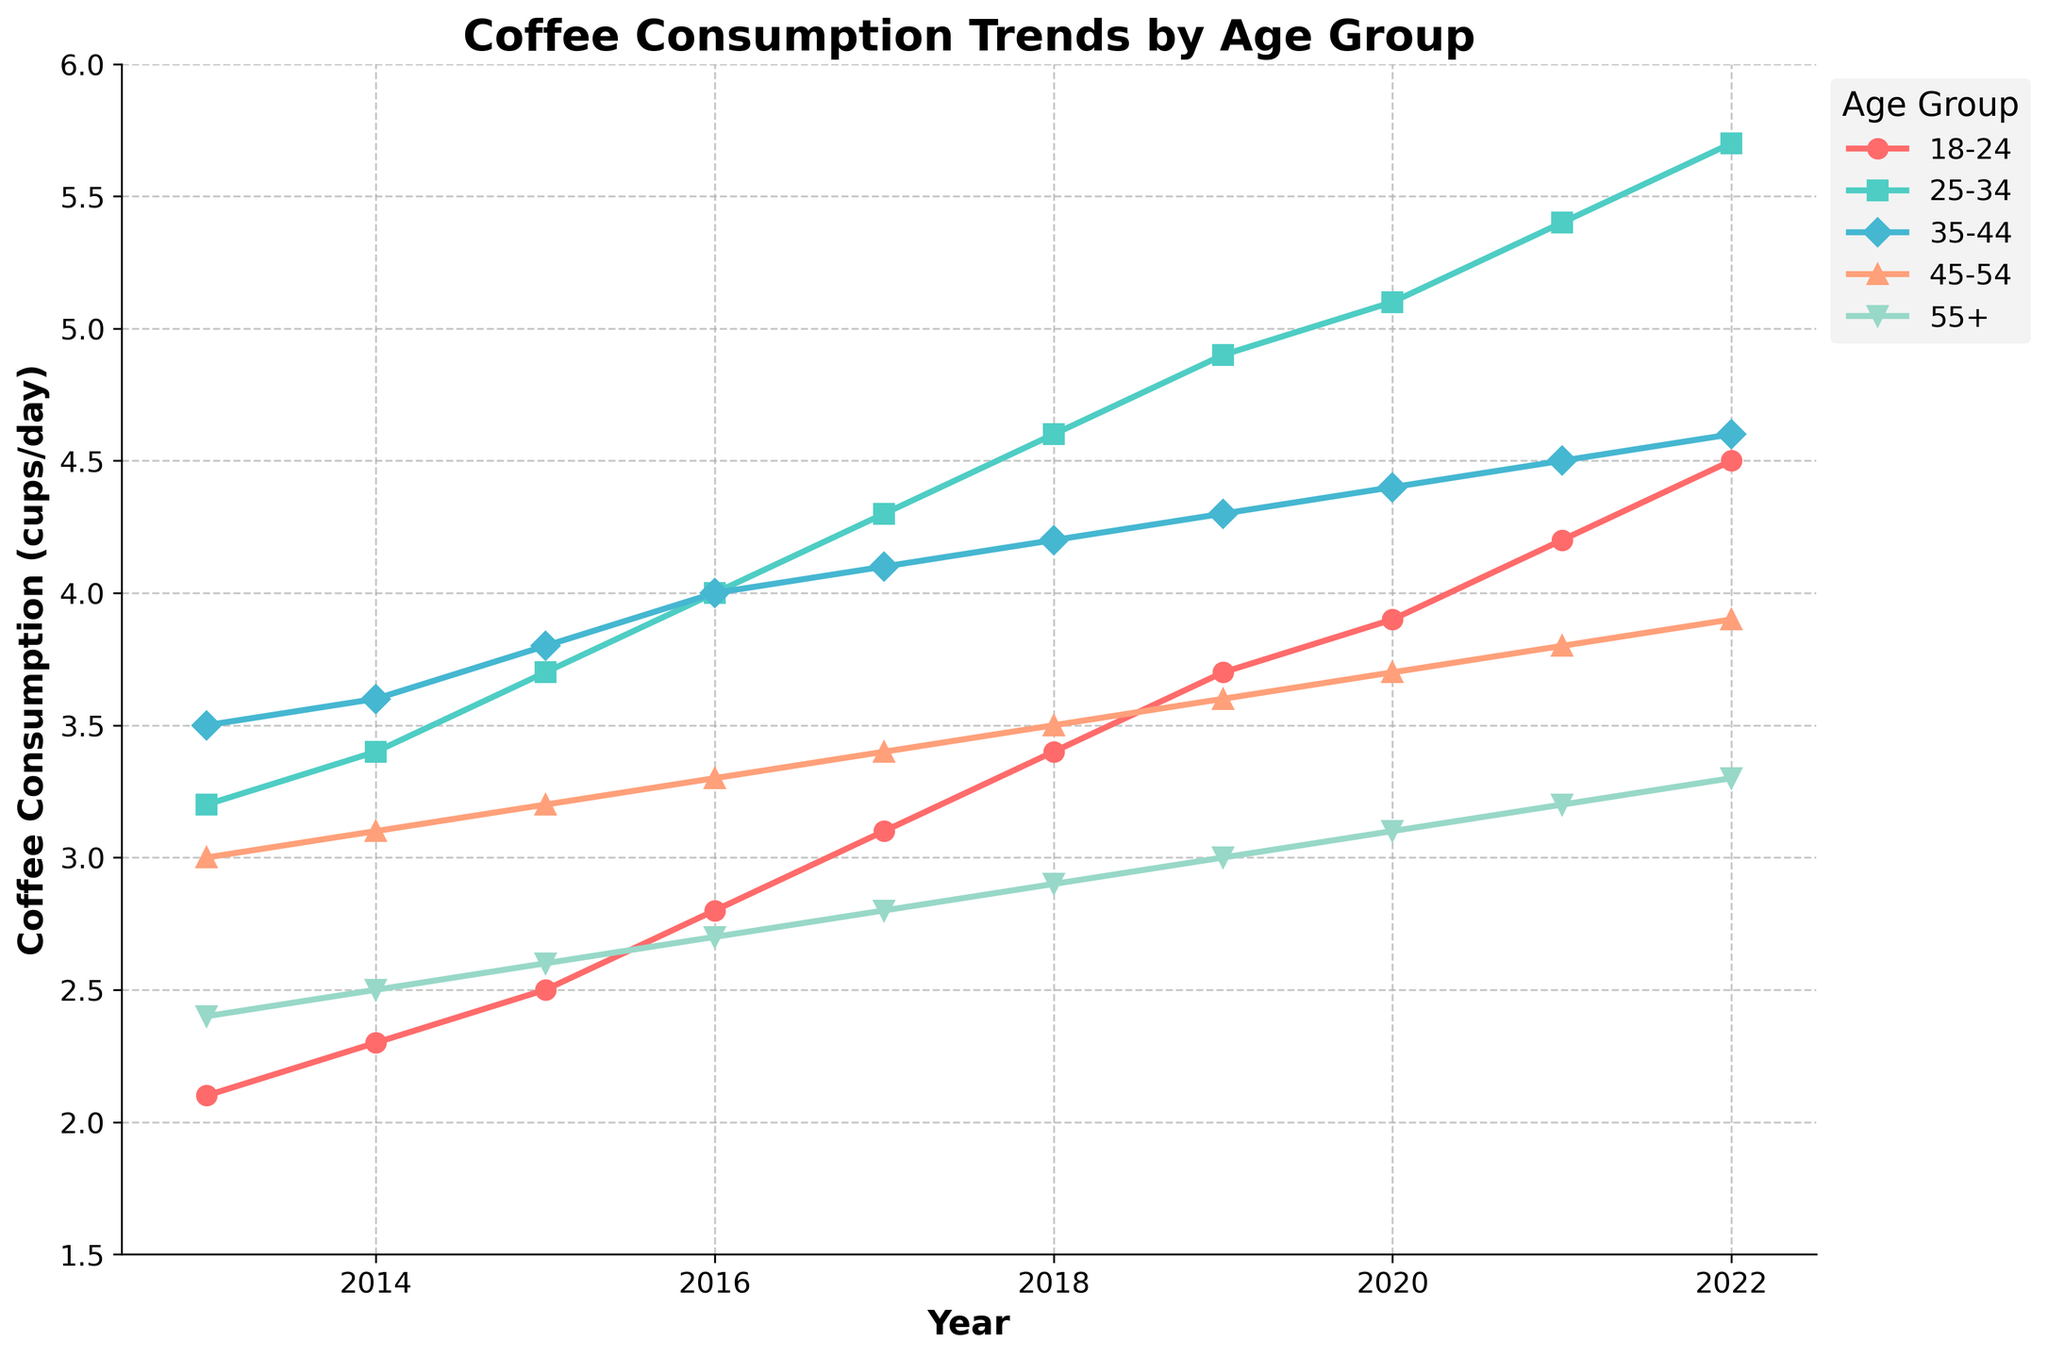Which age group had the highest coffee consumption in 2022? Look at the lines on the chart for each age group in 2022, the highest point will indicate the highest consumption. The 25-34 age group reaches 5.7 cups/day, which is the highest.
Answer: 25-34 What is the difference in coffee consumption between the 18-24 and 55+ age groups in 2020? Find the values for both age groups in 2020. The 18-24 group had 3.9 cups/day and the 55+ group had 3.1 cups/day. Subtract the smaller value from the larger: 3.9 - 3.1 = 0.8.
Answer: 0.8 Did coffee consumption for the 45-54 age group steadily increase from 2013 to 2022? Check the values for the 45-54 age group each year from 2013 to 2022. The values increase each year from 3.0 in 2013 to 3.9 in 2022.
Answer: Yes Between which consecutive years did the coffee consumption for the 25-34 age group see the largest increase? Calculate the yearly increase for the 25-34 age group and compare them. The largest increase is from 2017 to 2018 (4.6 - 4.3 = 0.3 cups/day).
Answer: 2017-2018 What is the average coffee consumption for the 35-44 age group over the decade? Sum the values for the 35-44 age group from 2013 to 2022 and then divide by the number of years (10). The sum is 39.0 cups, so the average is 39.0/10 = 3.9 cups/day.
Answer: 3.9 Which age group showed the most consistent increase in coffee consumption over the years? Analyze the trends for each age group. The 18-24 age group shows a steady and consistent increase each year without any decrease, indicating a consistent increase.
Answer: 18-24 How does the coffee consumption of the 45-54 age group in 2022 compare to its consumption in 2013? Look at the values for the 45-54 age group in 2013 and 2022. In 2013, the value is 3.0 cups/day, and in 2022 it is 3.9 cups/day. The consumption increased by 3.9 - 3.0 = 0.9 cups/day.
Answer: Increased by 0.9 Is there any year where the coffee consumption decreased for any age group? If yes, provide an example. Check each age group's yearly consumption values for any decreases. There are no decreases; each year, all age groups show an increase or remain the same.
Answer: No Compare the coffee consumption of the youngest and oldest age groups in 2019. Find the values for the 18-24 and 55+ age groups in 2019. The 18-24 group had 3.7 cups/day and the 55+ group had 3.0 cups/day. The 18-24 group consumed more by 3.7 - 3.0 = 0.7 cups/day.
Answer: The 18-24 age group consumed 0.7 more cups/day What is the total increase in coffee consumption for the 25-34 age group from 2013 to 2022? Subtract the value in 2013 from 2022 for the 25-34 age group. In 2013, it was 3.2 cups/day, and in 2022 it was 5.7 cups/day. The increase is 5.7 - 3.2 = 2.5 cups/day.
Answer: 2.5 cups/day 